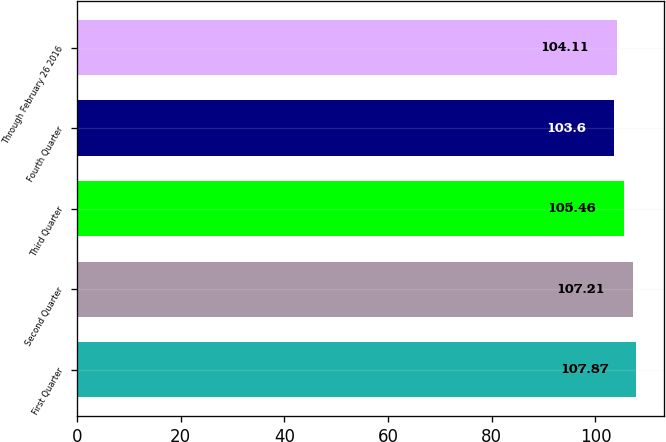<chart> <loc_0><loc_0><loc_500><loc_500><bar_chart><fcel>First Quarter<fcel>Second Quarter<fcel>Third Quarter<fcel>Fourth Quarter<fcel>Through February 26 2016<nl><fcel>107.87<fcel>107.21<fcel>105.46<fcel>103.6<fcel>104.11<nl></chart> 